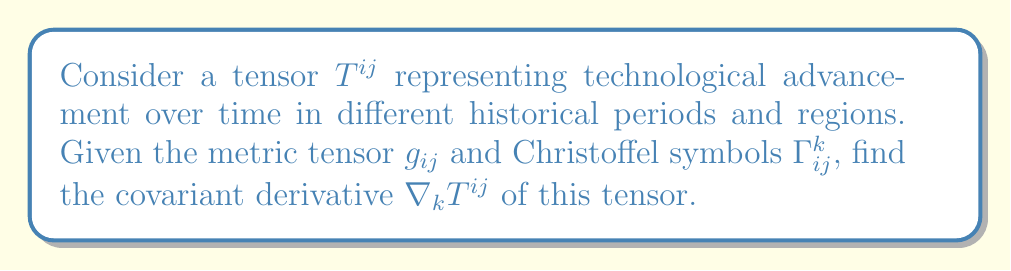Can you solve this math problem? To find the covariant derivative of the tensor $T^{ij}$, we follow these steps:

1. Recall the formula for the covariant derivative of a contravariant tensor:

   $$\nabla_k T^{ij} = \partial_k T^{ij} + \Gamma^i_{kl}T^{lj} + \Gamma^j_{kl}T^{il}$$

2. Break down the components:
   a) $\partial_k T^{ij}$ is the partial derivative of $T^{ij}$ with respect to $x^k$
   b) $\Gamma^i_{kl}T^{lj}$ represents the connection between different coordinate systems
   c) $\Gamma^j_{kl}T^{il}$ accounts for the curvature of the space

3. Calculate $\partial_k T^{ij}$:
   This term represents how technological advancement changes over time and space.

4. Compute $\Gamma^i_{kl}T^{lj}$:
   This term adjusts for how technological progress in one area affects others.

5. Determine $\Gamma^j_{kl}T^{il}$:
   This accounts for how the rate of technological advancement varies across different regions and periods.

6. Sum up all components to get the final result:
   $$\nabla_k T^{ij} = \partial_k T^{ij} + \Gamma^i_{kl}T^{lj} + \Gamma^j_{kl}T^{il}$$

This covariant derivative describes how technological advancement changes across different historical periods and regions, taking into account the interdependencies and varying rates of progress.
Answer: $$\nabla_k T^{ij} = \partial_k T^{ij} + \Gamma^i_{kl}T^{lj} + \Gamma^j_{kl}T^{il}$$ 